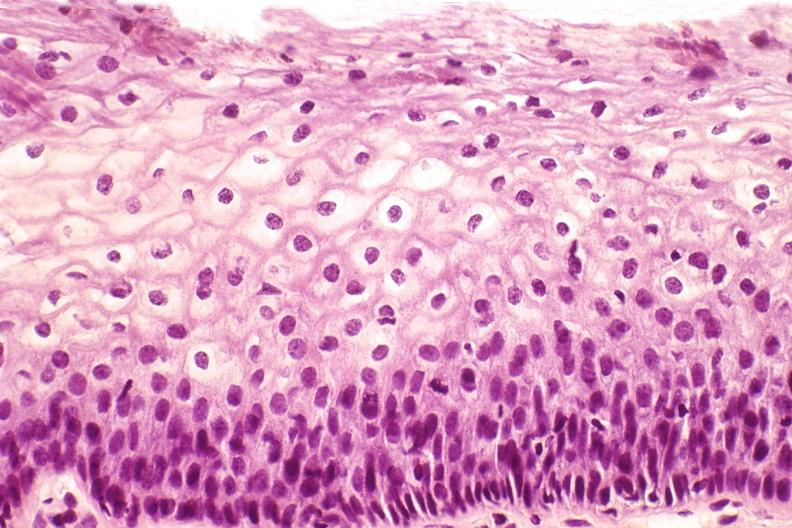what is present?
Answer the question using a single word or phrase. Female reproductive 